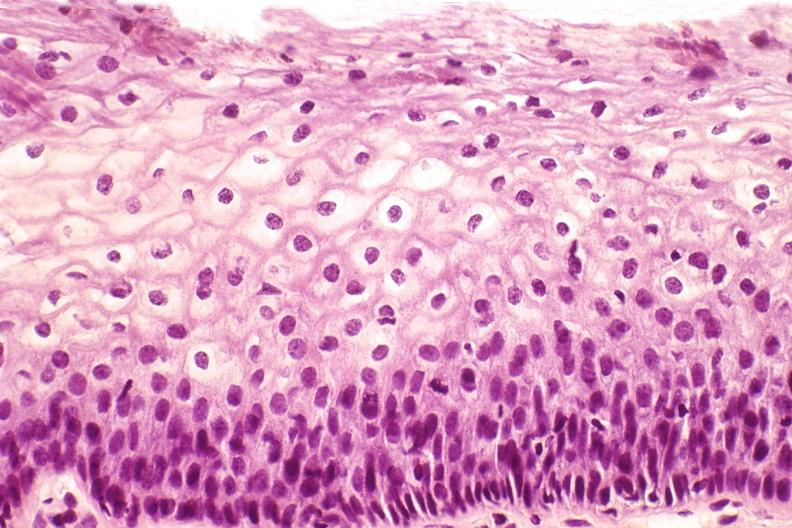what is present?
Answer the question using a single word or phrase. Female reproductive 